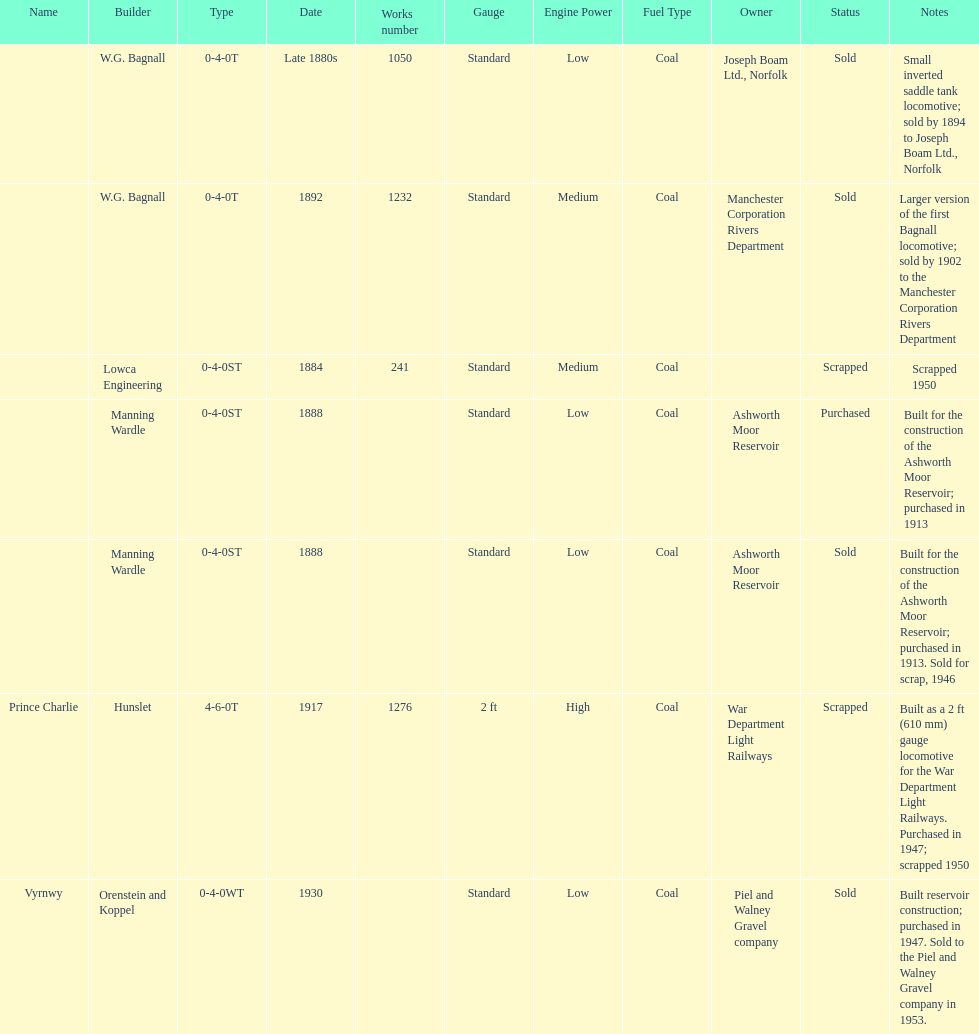Would you be able to parse every entry in this table? {'header': ['Name', 'Builder', 'Type', 'Date', 'Works number', 'Gauge', 'Engine Power', 'Fuel Type', 'Owner', 'Status', 'Notes'], 'rows': [['', 'W.G. Bagnall', '0-4-0T', 'Late 1880s', '1050', 'Standard', 'Low', 'Coal', 'Joseph Boam Ltd., Norfolk', 'Sold', 'Small inverted saddle tank locomotive; sold by 1894 to Joseph Boam Ltd., Norfolk'], ['', 'W.G. Bagnall', '0-4-0T', '1892', '1232', 'Standard', 'Medium', 'Coal', 'Manchester Corporation Rivers Department', 'Sold', 'Larger version of the first Bagnall locomotive; sold by 1902 to the Manchester Corporation Rivers Department'], ['', 'Lowca Engineering', '0-4-0ST', '1884', '241', 'Standard', 'Medium', 'Coal', '', 'Scrapped', 'Scrapped 1950'], ['', 'Manning Wardle', '0-4-0ST', '1888', '', 'Standard', 'Low', 'Coal', 'Ashworth Moor Reservoir', 'Purchased', 'Built for the construction of the Ashworth Moor Reservoir; purchased in 1913'], ['', 'Manning Wardle', '0-4-0ST', '1888', '', 'Standard', 'Low', 'Coal', 'Ashworth Moor Reservoir', 'Sold', 'Built for the construction of the Ashworth Moor Reservoir; purchased in 1913. Sold for scrap, 1946'], ['Prince Charlie', 'Hunslet', '4-6-0T', '1917', '1276', '2 ft', 'High', 'Coal', 'War Department Light Railways', 'Scrapped', 'Built as a 2\xa0ft (610\xa0mm) gauge locomotive for the War Department Light Railways. Purchased in 1947; scrapped 1950'], ['Vyrnwy', 'Orenstein and Koppel', '0-4-0WT', '1930', '', 'Standard', 'Low', 'Coal', 'Piel and Walney Gravel company', 'Sold', 'Built reservoir construction; purchased in 1947. Sold to the Piel and Walney Gravel company in 1953.']]} What was the last locomotive? Vyrnwy. 